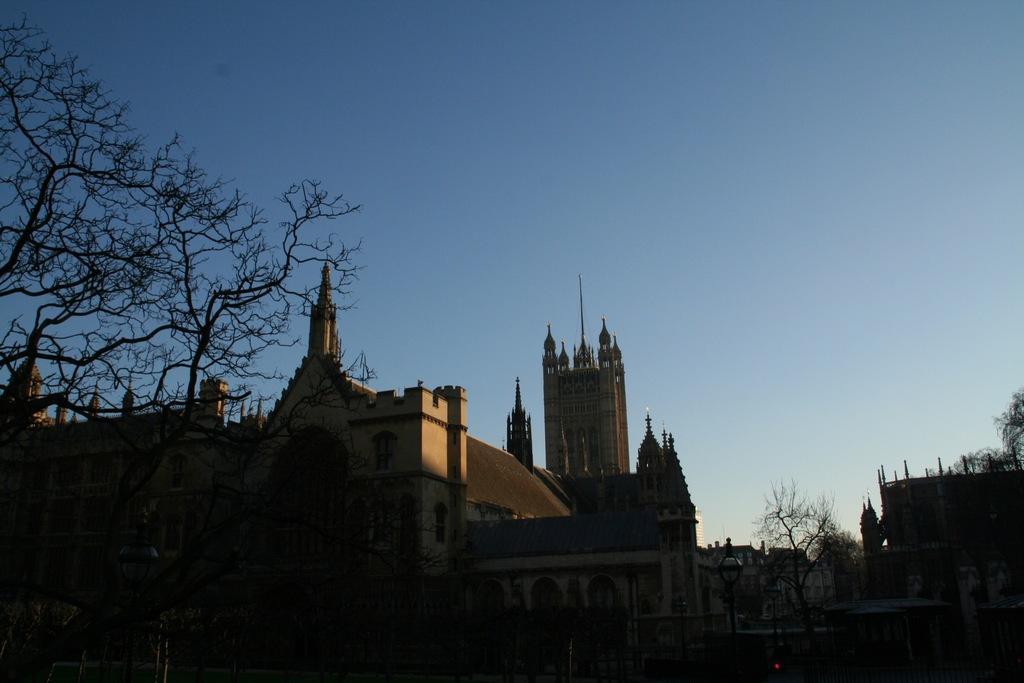In one or two sentences, can you explain what this image depicts? In the picture I can see trees, buildings and top of the picture there is clear sky. 